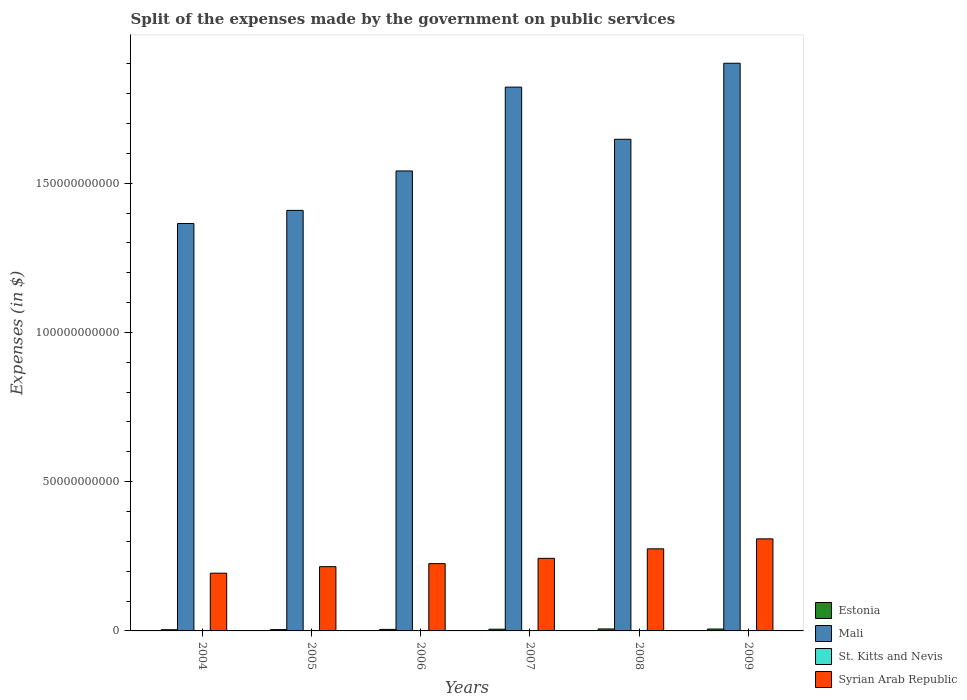How many groups of bars are there?
Give a very brief answer. 6. How many bars are there on the 6th tick from the right?
Offer a very short reply. 4. What is the label of the 2nd group of bars from the left?
Provide a succinct answer. 2005. In how many cases, is the number of bars for a given year not equal to the number of legend labels?
Your response must be concise. 0. What is the expenses made by the government on public services in Syrian Arab Republic in 2007?
Provide a short and direct response. 2.43e+1. Across all years, what is the maximum expenses made by the government on public services in Estonia?
Make the answer very short. 6.60e+08. Across all years, what is the minimum expenses made by the government on public services in Estonia?
Your answer should be very brief. 4.04e+08. In which year was the expenses made by the government on public services in Syrian Arab Republic maximum?
Give a very brief answer. 2009. In which year was the expenses made by the government on public services in Mali minimum?
Your response must be concise. 2004. What is the total expenses made by the government on public services in Estonia in the graph?
Give a very brief answer. 3.24e+09. What is the difference between the expenses made by the government on public services in Syrian Arab Republic in 2007 and that in 2009?
Ensure brevity in your answer.  -6.52e+09. What is the difference between the expenses made by the government on public services in Mali in 2008 and the expenses made by the government on public services in Estonia in 2004?
Give a very brief answer. 1.64e+11. What is the average expenses made by the government on public services in St. Kitts and Nevis per year?
Ensure brevity in your answer.  1.24e+08. In the year 2005, what is the difference between the expenses made by the government on public services in Estonia and expenses made by the government on public services in Syrian Arab Republic?
Make the answer very short. -2.11e+1. In how many years, is the expenses made by the government on public services in Estonia greater than 50000000000 $?
Make the answer very short. 0. What is the ratio of the expenses made by the government on public services in St. Kitts and Nevis in 2004 to that in 2005?
Make the answer very short. 0.84. What is the difference between the highest and the second highest expenses made by the government on public services in Syrian Arab Republic?
Your answer should be compact. 3.34e+09. What is the difference between the highest and the lowest expenses made by the government on public services in St. Kitts and Nevis?
Offer a very short reply. 4.46e+07. Is it the case that in every year, the sum of the expenses made by the government on public services in Mali and expenses made by the government on public services in Estonia is greater than the sum of expenses made by the government on public services in St. Kitts and Nevis and expenses made by the government on public services in Syrian Arab Republic?
Make the answer very short. Yes. What does the 3rd bar from the left in 2008 represents?
Make the answer very short. St. Kitts and Nevis. What does the 2nd bar from the right in 2007 represents?
Your answer should be very brief. St. Kitts and Nevis. Are all the bars in the graph horizontal?
Provide a succinct answer. No. Does the graph contain grids?
Keep it short and to the point. No. Where does the legend appear in the graph?
Provide a succinct answer. Bottom right. How are the legend labels stacked?
Provide a succinct answer. Vertical. What is the title of the graph?
Make the answer very short. Split of the expenses made by the government on public services. Does "Maldives" appear as one of the legend labels in the graph?
Your response must be concise. No. What is the label or title of the Y-axis?
Offer a very short reply. Expenses (in $). What is the Expenses (in $) of Estonia in 2004?
Offer a terse response. 4.04e+08. What is the Expenses (in $) of Mali in 2004?
Your answer should be compact. 1.36e+11. What is the Expenses (in $) in St. Kitts and Nevis in 2004?
Your answer should be compact. 9.58e+07. What is the Expenses (in $) in Syrian Arab Republic in 2004?
Provide a short and direct response. 1.93e+1. What is the Expenses (in $) of Estonia in 2005?
Provide a short and direct response. 4.46e+08. What is the Expenses (in $) of Mali in 2005?
Your answer should be compact. 1.41e+11. What is the Expenses (in $) in St. Kitts and Nevis in 2005?
Give a very brief answer. 1.15e+08. What is the Expenses (in $) in Syrian Arab Republic in 2005?
Your response must be concise. 2.15e+1. What is the Expenses (in $) of Estonia in 2006?
Offer a very short reply. 5.12e+08. What is the Expenses (in $) of Mali in 2006?
Your answer should be very brief. 1.54e+11. What is the Expenses (in $) in St. Kitts and Nevis in 2006?
Keep it short and to the point. 1.29e+08. What is the Expenses (in $) of Syrian Arab Republic in 2006?
Provide a succinct answer. 2.25e+1. What is the Expenses (in $) of Estonia in 2007?
Your answer should be compact. 5.78e+08. What is the Expenses (in $) in Mali in 2007?
Offer a very short reply. 1.82e+11. What is the Expenses (in $) of St. Kitts and Nevis in 2007?
Your answer should be compact. 1.40e+08. What is the Expenses (in $) in Syrian Arab Republic in 2007?
Your answer should be compact. 2.43e+1. What is the Expenses (in $) of Estonia in 2008?
Provide a short and direct response. 6.60e+08. What is the Expenses (in $) in Mali in 2008?
Make the answer very short. 1.65e+11. What is the Expenses (in $) in St. Kitts and Nevis in 2008?
Keep it short and to the point. 1.37e+08. What is the Expenses (in $) in Syrian Arab Republic in 2008?
Your answer should be very brief. 2.75e+1. What is the Expenses (in $) in Estonia in 2009?
Your answer should be compact. 6.36e+08. What is the Expenses (in $) in Mali in 2009?
Provide a short and direct response. 1.90e+11. What is the Expenses (in $) in St. Kitts and Nevis in 2009?
Your answer should be compact. 1.29e+08. What is the Expenses (in $) of Syrian Arab Republic in 2009?
Keep it short and to the point. 3.08e+1. Across all years, what is the maximum Expenses (in $) of Estonia?
Provide a short and direct response. 6.60e+08. Across all years, what is the maximum Expenses (in $) of Mali?
Keep it short and to the point. 1.90e+11. Across all years, what is the maximum Expenses (in $) of St. Kitts and Nevis?
Offer a very short reply. 1.40e+08. Across all years, what is the maximum Expenses (in $) in Syrian Arab Republic?
Make the answer very short. 3.08e+1. Across all years, what is the minimum Expenses (in $) of Estonia?
Make the answer very short. 4.04e+08. Across all years, what is the minimum Expenses (in $) in Mali?
Offer a terse response. 1.36e+11. Across all years, what is the minimum Expenses (in $) of St. Kitts and Nevis?
Keep it short and to the point. 9.58e+07. Across all years, what is the minimum Expenses (in $) in Syrian Arab Republic?
Ensure brevity in your answer.  1.93e+1. What is the total Expenses (in $) in Estonia in the graph?
Make the answer very short. 3.24e+09. What is the total Expenses (in $) in Mali in the graph?
Provide a short and direct response. 9.69e+11. What is the total Expenses (in $) in St. Kitts and Nevis in the graph?
Your response must be concise. 7.47e+08. What is the total Expenses (in $) in Syrian Arab Republic in the graph?
Ensure brevity in your answer.  1.46e+11. What is the difference between the Expenses (in $) of Estonia in 2004 and that in 2005?
Keep it short and to the point. -4.19e+07. What is the difference between the Expenses (in $) of Mali in 2004 and that in 2005?
Your answer should be compact. -4.40e+09. What is the difference between the Expenses (in $) of St. Kitts and Nevis in 2004 and that in 2005?
Give a very brief answer. -1.89e+07. What is the difference between the Expenses (in $) of Syrian Arab Republic in 2004 and that in 2005?
Give a very brief answer. -2.19e+09. What is the difference between the Expenses (in $) of Estonia in 2004 and that in 2006?
Offer a very short reply. -1.07e+08. What is the difference between the Expenses (in $) of Mali in 2004 and that in 2006?
Keep it short and to the point. -1.76e+1. What is the difference between the Expenses (in $) of St. Kitts and Nevis in 2004 and that in 2006?
Provide a succinct answer. -3.36e+07. What is the difference between the Expenses (in $) in Syrian Arab Republic in 2004 and that in 2006?
Ensure brevity in your answer.  -3.20e+09. What is the difference between the Expenses (in $) in Estonia in 2004 and that in 2007?
Your answer should be very brief. -1.74e+08. What is the difference between the Expenses (in $) of Mali in 2004 and that in 2007?
Give a very brief answer. -4.57e+1. What is the difference between the Expenses (in $) of St. Kitts and Nevis in 2004 and that in 2007?
Your answer should be compact. -4.46e+07. What is the difference between the Expenses (in $) in Syrian Arab Republic in 2004 and that in 2007?
Your response must be concise. -4.97e+09. What is the difference between the Expenses (in $) of Estonia in 2004 and that in 2008?
Your response must be concise. -2.56e+08. What is the difference between the Expenses (in $) of Mali in 2004 and that in 2008?
Provide a succinct answer. -2.82e+1. What is the difference between the Expenses (in $) of St. Kitts and Nevis in 2004 and that in 2008?
Offer a very short reply. -4.14e+07. What is the difference between the Expenses (in $) in Syrian Arab Republic in 2004 and that in 2008?
Offer a terse response. -8.16e+09. What is the difference between the Expenses (in $) in Estonia in 2004 and that in 2009?
Make the answer very short. -2.32e+08. What is the difference between the Expenses (in $) of Mali in 2004 and that in 2009?
Provide a short and direct response. -5.37e+1. What is the difference between the Expenses (in $) of St. Kitts and Nevis in 2004 and that in 2009?
Offer a terse response. -3.33e+07. What is the difference between the Expenses (in $) in Syrian Arab Republic in 2004 and that in 2009?
Your answer should be compact. -1.15e+1. What is the difference between the Expenses (in $) in Estonia in 2005 and that in 2006?
Provide a succinct answer. -6.51e+07. What is the difference between the Expenses (in $) in Mali in 2005 and that in 2006?
Offer a terse response. -1.32e+1. What is the difference between the Expenses (in $) in St. Kitts and Nevis in 2005 and that in 2006?
Provide a succinct answer. -1.47e+07. What is the difference between the Expenses (in $) of Syrian Arab Republic in 2005 and that in 2006?
Ensure brevity in your answer.  -1.01e+09. What is the difference between the Expenses (in $) of Estonia in 2005 and that in 2007?
Your answer should be compact. -1.32e+08. What is the difference between the Expenses (in $) in Mali in 2005 and that in 2007?
Give a very brief answer. -4.13e+1. What is the difference between the Expenses (in $) in St. Kitts and Nevis in 2005 and that in 2007?
Your answer should be compact. -2.57e+07. What is the difference between the Expenses (in $) of Syrian Arab Republic in 2005 and that in 2007?
Ensure brevity in your answer.  -2.79e+09. What is the difference between the Expenses (in $) of Estonia in 2005 and that in 2008?
Give a very brief answer. -2.14e+08. What is the difference between the Expenses (in $) in Mali in 2005 and that in 2008?
Offer a very short reply. -2.38e+1. What is the difference between the Expenses (in $) in St. Kitts and Nevis in 2005 and that in 2008?
Your answer should be very brief. -2.25e+07. What is the difference between the Expenses (in $) of Syrian Arab Republic in 2005 and that in 2008?
Provide a short and direct response. -5.97e+09. What is the difference between the Expenses (in $) in Estonia in 2005 and that in 2009?
Provide a short and direct response. -1.90e+08. What is the difference between the Expenses (in $) of Mali in 2005 and that in 2009?
Keep it short and to the point. -4.93e+1. What is the difference between the Expenses (in $) in St. Kitts and Nevis in 2005 and that in 2009?
Your answer should be compact. -1.44e+07. What is the difference between the Expenses (in $) in Syrian Arab Republic in 2005 and that in 2009?
Your response must be concise. -9.31e+09. What is the difference between the Expenses (in $) in Estonia in 2006 and that in 2007?
Your answer should be compact. -6.65e+07. What is the difference between the Expenses (in $) of Mali in 2006 and that in 2007?
Provide a succinct answer. -2.81e+1. What is the difference between the Expenses (in $) of St. Kitts and Nevis in 2006 and that in 2007?
Your response must be concise. -1.10e+07. What is the difference between the Expenses (in $) of Syrian Arab Republic in 2006 and that in 2007?
Keep it short and to the point. -1.78e+09. What is the difference between the Expenses (in $) in Estonia in 2006 and that in 2008?
Give a very brief answer. -1.49e+08. What is the difference between the Expenses (in $) in Mali in 2006 and that in 2008?
Your answer should be very brief. -1.06e+1. What is the difference between the Expenses (in $) in St. Kitts and Nevis in 2006 and that in 2008?
Provide a succinct answer. -7.80e+06. What is the difference between the Expenses (in $) of Syrian Arab Republic in 2006 and that in 2008?
Ensure brevity in your answer.  -4.96e+09. What is the difference between the Expenses (in $) of Estonia in 2006 and that in 2009?
Your answer should be compact. -1.25e+08. What is the difference between the Expenses (in $) of Mali in 2006 and that in 2009?
Your response must be concise. -3.61e+1. What is the difference between the Expenses (in $) in St. Kitts and Nevis in 2006 and that in 2009?
Your answer should be very brief. 3.00e+05. What is the difference between the Expenses (in $) in Syrian Arab Republic in 2006 and that in 2009?
Provide a succinct answer. -8.30e+09. What is the difference between the Expenses (in $) in Estonia in 2007 and that in 2008?
Make the answer very short. -8.21e+07. What is the difference between the Expenses (in $) of Mali in 2007 and that in 2008?
Your response must be concise. 1.75e+1. What is the difference between the Expenses (in $) of St. Kitts and Nevis in 2007 and that in 2008?
Offer a very short reply. 3.20e+06. What is the difference between the Expenses (in $) in Syrian Arab Republic in 2007 and that in 2008?
Give a very brief answer. -3.19e+09. What is the difference between the Expenses (in $) in Estonia in 2007 and that in 2009?
Keep it short and to the point. -5.85e+07. What is the difference between the Expenses (in $) of Mali in 2007 and that in 2009?
Keep it short and to the point. -8.00e+09. What is the difference between the Expenses (in $) of St. Kitts and Nevis in 2007 and that in 2009?
Provide a short and direct response. 1.13e+07. What is the difference between the Expenses (in $) of Syrian Arab Republic in 2007 and that in 2009?
Keep it short and to the point. -6.52e+09. What is the difference between the Expenses (in $) of Estonia in 2008 and that in 2009?
Make the answer very short. 2.36e+07. What is the difference between the Expenses (in $) of Mali in 2008 and that in 2009?
Keep it short and to the point. -2.55e+1. What is the difference between the Expenses (in $) in St. Kitts and Nevis in 2008 and that in 2009?
Your response must be concise. 8.10e+06. What is the difference between the Expenses (in $) of Syrian Arab Republic in 2008 and that in 2009?
Make the answer very short. -3.34e+09. What is the difference between the Expenses (in $) in Estonia in 2004 and the Expenses (in $) in Mali in 2005?
Keep it short and to the point. -1.40e+11. What is the difference between the Expenses (in $) of Estonia in 2004 and the Expenses (in $) of St. Kitts and Nevis in 2005?
Give a very brief answer. 2.90e+08. What is the difference between the Expenses (in $) of Estonia in 2004 and the Expenses (in $) of Syrian Arab Republic in 2005?
Keep it short and to the point. -2.11e+1. What is the difference between the Expenses (in $) in Mali in 2004 and the Expenses (in $) in St. Kitts and Nevis in 2005?
Keep it short and to the point. 1.36e+11. What is the difference between the Expenses (in $) of Mali in 2004 and the Expenses (in $) of Syrian Arab Republic in 2005?
Make the answer very short. 1.15e+11. What is the difference between the Expenses (in $) in St. Kitts and Nevis in 2004 and the Expenses (in $) in Syrian Arab Republic in 2005?
Offer a terse response. -2.14e+1. What is the difference between the Expenses (in $) in Estonia in 2004 and the Expenses (in $) in Mali in 2006?
Ensure brevity in your answer.  -1.54e+11. What is the difference between the Expenses (in $) in Estonia in 2004 and the Expenses (in $) in St. Kitts and Nevis in 2006?
Keep it short and to the point. 2.75e+08. What is the difference between the Expenses (in $) of Estonia in 2004 and the Expenses (in $) of Syrian Arab Republic in 2006?
Keep it short and to the point. -2.21e+1. What is the difference between the Expenses (in $) in Mali in 2004 and the Expenses (in $) in St. Kitts and Nevis in 2006?
Provide a short and direct response. 1.36e+11. What is the difference between the Expenses (in $) in Mali in 2004 and the Expenses (in $) in Syrian Arab Republic in 2006?
Ensure brevity in your answer.  1.14e+11. What is the difference between the Expenses (in $) in St. Kitts and Nevis in 2004 and the Expenses (in $) in Syrian Arab Republic in 2006?
Offer a terse response. -2.25e+1. What is the difference between the Expenses (in $) of Estonia in 2004 and the Expenses (in $) of Mali in 2007?
Offer a very short reply. -1.82e+11. What is the difference between the Expenses (in $) of Estonia in 2004 and the Expenses (in $) of St. Kitts and Nevis in 2007?
Offer a terse response. 2.64e+08. What is the difference between the Expenses (in $) in Estonia in 2004 and the Expenses (in $) in Syrian Arab Republic in 2007?
Make the answer very short. -2.39e+1. What is the difference between the Expenses (in $) of Mali in 2004 and the Expenses (in $) of St. Kitts and Nevis in 2007?
Make the answer very short. 1.36e+11. What is the difference between the Expenses (in $) in Mali in 2004 and the Expenses (in $) in Syrian Arab Republic in 2007?
Your answer should be very brief. 1.12e+11. What is the difference between the Expenses (in $) of St. Kitts and Nevis in 2004 and the Expenses (in $) of Syrian Arab Republic in 2007?
Your answer should be very brief. -2.42e+1. What is the difference between the Expenses (in $) of Estonia in 2004 and the Expenses (in $) of Mali in 2008?
Your response must be concise. -1.64e+11. What is the difference between the Expenses (in $) in Estonia in 2004 and the Expenses (in $) in St. Kitts and Nevis in 2008?
Ensure brevity in your answer.  2.67e+08. What is the difference between the Expenses (in $) in Estonia in 2004 and the Expenses (in $) in Syrian Arab Republic in 2008?
Ensure brevity in your answer.  -2.71e+1. What is the difference between the Expenses (in $) of Mali in 2004 and the Expenses (in $) of St. Kitts and Nevis in 2008?
Offer a very short reply. 1.36e+11. What is the difference between the Expenses (in $) of Mali in 2004 and the Expenses (in $) of Syrian Arab Republic in 2008?
Keep it short and to the point. 1.09e+11. What is the difference between the Expenses (in $) of St. Kitts and Nevis in 2004 and the Expenses (in $) of Syrian Arab Republic in 2008?
Your response must be concise. -2.74e+1. What is the difference between the Expenses (in $) in Estonia in 2004 and the Expenses (in $) in Mali in 2009?
Offer a terse response. -1.90e+11. What is the difference between the Expenses (in $) of Estonia in 2004 and the Expenses (in $) of St. Kitts and Nevis in 2009?
Your answer should be compact. 2.75e+08. What is the difference between the Expenses (in $) in Estonia in 2004 and the Expenses (in $) in Syrian Arab Republic in 2009?
Your answer should be compact. -3.04e+1. What is the difference between the Expenses (in $) of Mali in 2004 and the Expenses (in $) of St. Kitts and Nevis in 2009?
Provide a succinct answer. 1.36e+11. What is the difference between the Expenses (in $) in Mali in 2004 and the Expenses (in $) in Syrian Arab Republic in 2009?
Offer a terse response. 1.06e+11. What is the difference between the Expenses (in $) in St. Kitts and Nevis in 2004 and the Expenses (in $) in Syrian Arab Republic in 2009?
Your response must be concise. -3.07e+1. What is the difference between the Expenses (in $) in Estonia in 2005 and the Expenses (in $) in Mali in 2006?
Make the answer very short. -1.54e+11. What is the difference between the Expenses (in $) of Estonia in 2005 and the Expenses (in $) of St. Kitts and Nevis in 2006?
Provide a succinct answer. 3.17e+08. What is the difference between the Expenses (in $) of Estonia in 2005 and the Expenses (in $) of Syrian Arab Republic in 2006?
Provide a succinct answer. -2.21e+1. What is the difference between the Expenses (in $) in Mali in 2005 and the Expenses (in $) in St. Kitts and Nevis in 2006?
Make the answer very short. 1.41e+11. What is the difference between the Expenses (in $) in Mali in 2005 and the Expenses (in $) in Syrian Arab Republic in 2006?
Offer a terse response. 1.18e+11. What is the difference between the Expenses (in $) of St. Kitts and Nevis in 2005 and the Expenses (in $) of Syrian Arab Republic in 2006?
Make the answer very short. -2.24e+1. What is the difference between the Expenses (in $) in Estonia in 2005 and the Expenses (in $) in Mali in 2007?
Make the answer very short. -1.82e+11. What is the difference between the Expenses (in $) in Estonia in 2005 and the Expenses (in $) in St. Kitts and Nevis in 2007?
Offer a very short reply. 3.06e+08. What is the difference between the Expenses (in $) of Estonia in 2005 and the Expenses (in $) of Syrian Arab Republic in 2007?
Provide a succinct answer. -2.39e+1. What is the difference between the Expenses (in $) in Mali in 2005 and the Expenses (in $) in St. Kitts and Nevis in 2007?
Your answer should be very brief. 1.41e+11. What is the difference between the Expenses (in $) in Mali in 2005 and the Expenses (in $) in Syrian Arab Republic in 2007?
Ensure brevity in your answer.  1.17e+11. What is the difference between the Expenses (in $) of St. Kitts and Nevis in 2005 and the Expenses (in $) of Syrian Arab Republic in 2007?
Your response must be concise. -2.42e+1. What is the difference between the Expenses (in $) in Estonia in 2005 and the Expenses (in $) in Mali in 2008?
Your answer should be very brief. -1.64e+11. What is the difference between the Expenses (in $) of Estonia in 2005 and the Expenses (in $) of St. Kitts and Nevis in 2008?
Make the answer very short. 3.09e+08. What is the difference between the Expenses (in $) in Estonia in 2005 and the Expenses (in $) in Syrian Arab Republic in 2008?
Ensure brevity in your answer.  -2.71e+1. What is the difference between the Expenses (in $) of Mali in 2005 and the Expenses (in $) of St. Kitts and Nevis in 2008?
Offer a terse response. 1.41e+11. What is the difference between the Expenses (in $) in Mali in 2005 and the Expenses (in $) in Syrian Arab Republic in 2008?
Make the answer very short. 1.13e+11. What is the difference between the Expenses (in $) of St. Kitts and Nevis in 2005 and the Expenses (in $) of Syrian Arab Republic in 2008?
Give a very brief answer. -2.74e+1. What is the difference between the Expenses (in $) in Estonia in 2005 and the Expenses (in $) in Mali in 2009?
Provide a short and direct response. -1.90e+11. What is the difference between the Expenses (in $) of Estonia in 2005 and the Expenses (in $) of St. Kitts and Nevis in 2009?
Give a very brief answer. 3.17e+08. What is the difference between the Expenses (in $) in Estonia in 2005 and the Expenses (in $) in Syrian Arab Republic in 2009?
Your answer should be compact. -3.04e+1. What is the difference between the Expenses (in $) in Mali in 2005 and the Expenses (in $) in St. Kitts and Nevis in 2009?
Make the answer very short. 1.41e+11. What is the difference between the Expenses (in $) of Mali in 2005 and the Expenses (in $) of Syrian Arab Republic in 2009?
Your response must be concise. 1.10e+11. What is the difference between the Expenses (in $) in St. Kitts and Nevis in 2005 and the Expenses (in $) in Syrian Arab Republic in 2009?
Ensure brevity in your answer.  -3.07e+1. What is the difference between the Expenses (in $) of Estonia in 2006 and the Expenses (in $) of Mali in 2007?
Make the answer very short. -1.82e+11. What is the difference between the Expenses (in $) in Estonia in 2006 and the Expenses (in $) in St. Kitts and Nevis in 2007?
Offer a terse response. 3.71e+08. What is the difference between the Expenses (in $) of Estonia in 2006 and the Expenses (in $) of Syrian Arab Republic in 2007?
Give a very brief answer. -2.38e+1. What is the difference between the Expenses (in $) of Mali in 2006 and the Expenses (in $) of St. Kitts and Nevis in 2007?
Provide a short and direct response. 1.54e+11. What is the difference between the Expenses (in $) in Mali in 2006 and the Expenses (in $) in Syrian Arab Republic in 2007?
Your response must be concise. 1.30e+11. What is the difference between the Expenses (in $) of St. Kitts and Nevis in 2006 and the Expenses (in $) of Syrian Arab Republic in 2007?
Your response must be concise. -2.42e+1. What is the difference between the Expenses (in $) in Estonia in 2006 and the Expenses (in $) in Mali in 2008?
Keep it short and to the point. -1.64e+11. What is the difference between the Expenses (in $) of Estonia in 2006 and the Expenses (in $) of St. Kitts and Nevis in 2008?
Keep it short and to the point. 3.74e+08. What is the difference between the Expenses (in $) of Estonia in 2006 and the Expenses (in $) of Syrian Arab Republic in 2008?
Provide a short and direct response. -2.70e+1. What is the difference between the Expenses (in $) of Mali in 2006 and the Expenses (in $) of St. Kitts and Nevis in 2008?
Your answer should be compact. 1.54e+11. What is the difference between the Expenses (in $) in Mali in 2006 and the Expenses (in $) in Syrian Arab Republic in 2008?
Keep it short and to the point. 1.27e+11. What is the difference between the Expenses (in $) in St. Kitts and Nevis in 2006 and the Expenses (in $) in Syrian Arab Republic in 2008?
Your response must be concise. -2.74e+1. What is the difference between the Expenses (in $) in Estonia in 2006 and the Expenses (in $) in Mali in 2009?
Offer a very short reply. -1.90e+11. What is the difference between the Expenses (in $) in Estonia in 2006 and the Expenses (in $) in St. Kitts and Nevis in 2009?
Offer a very short reply. 3.82e+08. What is the difference between the Expenses (in $) in Estonia in 2006 and the Expenses (in $) in Syrian Arab Republic in 2009?
Offer a terse response. -3.03e+1. What is the difference between the Expenses (in $) in Mali in 2006 and the Expenses (in $) in St. Kitts and Nevis in 2009?
Provide a short and direct response. 1.54e+11. What is the difference between the Expenses (in $) in Mali in 2006 and the Expenses (in $) in Syrian Arab Republic in 2009?
Your response must be concise. 1.23e+11. What is the difference between the Expenses (in $) in St. Kitts and Nevis in 2006 and the Expenses (in $) in Syrian Arab Republic in 2009?
Give a very brief answer. -3.07e+1. What is the difference between the Expenses (in $) of Estonia in 2007 and the Expenses (in $) of Mali in 2008?
Keep it short and to the point. -1.64e+11. What is the difference between the Expenses (in $) of Estonia in 2007 and the Expenses (in $) of St. Kitts and Nevis in 2008?
Provide a short and direct response. 4.41e+08. What is the difference between the Expenses (in $) of Estonia in 2007 and the Expenses (in $) of Syrian Arab Republic in 2008?
Your answer should be compact. -2.69e+1. What is the difference between the Expenses (in $) in Mali in 2007 and the Expenses (in $) in St. Kitts and Nevis in 2008?
Provide a succinct answer. 1.82e+11. What is the difference between the Expenses (in $) of Mali in 2007 and the Expenses (in $) of Syrian Arab Republic in 2008?
Your answer should be compact. 1.55e+11. What is the difference between the Expenses (in $) of St. Kitts and Nevis in 2007 and the Expenses (in $) of Syrian Arab Republic in 2008?
Offer a terse response. -2.74e+1. What is the difference between the Expenses (in $) of Estonia in 2007 and the Expenses (in $) of Mali in 2009?
Offer a very short reply. -1.90e+11. What is the difference between the Expenses (in $) of Estonia in 2007 and the Expenses (in $) of St. Kitts and Nevis in 2009?
Your response must be concise. 4.49e+08. What is the difference between the Expenses (in $) of Estonia in 2007 and the Expenses (in $) of Syrian Arab Republic in 2009?
Give a very brief answer. -3.03e+1. What is the difference between the Expenses (in $) in Mali in 2007 and the Expenses (in $) in St. Kitts and Nevis in 2009?
Give a very brief answer. 1.82e+11. What is the difference between the Expenses (in $) of Mali in 2007 and the Expenses (in $) of Syrian Arab Republic in 2009?
Offer a very short reply. 1.51e+11. What is the difference between the Expenses (in $) in St. Kitts and Nevis in 2007 and the Expenses (in $) in Syrian Arab Republic in 2009?
Provide a short and direct response. -3.07e+1. What is the difference between the Expenses (in $) in Estonia in 2008 and the Expenses (in $) in Mali in 2009?
Give a very brief answer. -1.90e+11. What is the difference between the Expenses (in $) in Estonia in 2008 and the Expenses (in $) in St. Kitts and Nevis in 2009?
Your answer should be compact. 5.31e+08. What is the difference between the Expenses (in $) in Estonia in 2008 and the Expenses (in $) in Syrian Arab Republic in 2009?
Keep it short and to the point. -3.02e+1. What is the difference between the Expenses (in $) in Mali in 2008 and the Expenses (in $) in St. Kitts and Nevis in 2009?
Make the answer very short. 1.65e+11. What is the difference between the Expenses (in $) of Mali in 2008 and the Expenses (in $) of Syrian Arab Republic in 2009?
Make the answer very short. 1.34e+11. What is the difference between the Expenses (in $) of St. Kitts and Nevis in 2008 and the Expenses (in $) of Syrian Arab Republic in 2009?
Your answer should be compact. -3.07e+1. What is the average Expenses (in $) in Estonia per year?
Offer a very short reply. 5.40e+08. What is the average Expenses (in $) of Mali per year?
Your answer should be compact. 1.61e+11. What is the average Expenses (in $) in St. Kitts and Nevis per year?
Keep it short and to the point. 1.24e+08. What is the average Expenses (in $) in Syrian Arab Republic per year?
Provide a succinct answer. 2.44e+1. In the year 2004, what is the difference between the Expenses (in $) of Estonia and Expenses (in $) of Mali?
Give a very brief answer. -1.36e+11. In the year 2004, what is the difference between the Expenses (in $) in Estonia and Expenses (in $) in St. Kitts and Nevis?
Keep it short and to the point. 3.09e+08. In the year 2004, what is the difference between the Expenses (in $) in Estonia and Expenses (in $) in Syrian Arab Republic?
Your answer should be very brief. -1.89e+1. In the year 2004, what is the difference between the Expenses (in $) in Mali and Expenses (in $) in St. Kitts and Nevis?
Keep it short and to the point. 1.36e+11. In the year 2004, what is the difference between the Expenses (in $) of Mali and Expenses (in $) of Syrian Arab Republic?
Your response must be concise. 1.17e+11. In the year 2004, what is the difference between the Expenses (in $) of St. Kitts and Nevis and Expenses (in $) of Syrian Arab Republic?
Give a very brief answer. -1.93e+1. In the year 2005, what is the difference between the Expenses (in $) in Estonia and Expenses (in $) in Mali?
Provide a succinct answer. -1.40e+11. In the year 2005, what is the difference between the Expenses (in $) of Estonia and Expenses (in $) of St. Kitts and Nevis?
Your response must be concise. 3.32e+08. In the year 2005, what is the difference between the Expenses (in $) of Estonia and Expenses (in $) of Syrian Arab Republic?
Provide a succinct answer. -2.11e+1. In the year 2005, what is the difference between the Expenses (in $) of Mali and Expenses (in $) of St. Kitts and Nevis?
Ensure brevity in your answer.  1.41e+11. In the year 2005, what is the difference between the Expenses (in $) of Mali and Expenses (in $) of Syrian Arab Republic?
Offer a very short reply. 1.19e+11. In the year 2005, what is the difference between the Expenses (in $) of St. Kitts and Nevis and Expenses (in $) of Syrian Arab Republic?
Offer a terse response. -2.14e+1. In the year 2006, what is the difference between the Expenses (in $) in Estonia and Expenses (in $) in Mali?
Provide a succinct answer. -1.54e+11. In the year 2006, what is the difference between the Expenses (in $) of Estonia and Expenses (in $) of St. Kitts and Nevis?
Offer a very short reply. 3.82e+08. In the year 2006, what is the difference between the Expenses (in $) in Estonia and Expenses (in $) in Syrian Arab Republic?
Offer a very short reply. -2.20e+1. In the year 2006, what is the difference between the Expenses (in $) in Mali and Expenses (in $) in St. Kitts and Nevis?
Your response must be concise. 1.54e+11. In the year 2006, what is the difference between the Expenses (in $) in Mali and Expenses (in $) in Syrian Arab Republic?
Your answer should be compact. 1.32e+11. In the year 2006, what is the difference between the Expenses (in $) in St. Kitts and Nevis and Expenses (in $) in Syrian Arab Republic?
Offer a terse response. -2.24e+1. In the year 2007, what is the difference between the Expenses (in $) of Estonia and Expenses (in $) of Mali?
Make the answer very short. -1.82e+11. In the year 2007, what is the difference between the Expenses (in $) in Estonia and Expenses (in $) in St. Kitts and Nevis?
Offer a very short reply. 4.38e+08. In the year 2007, what is the difference between the Expenses (in $) of Estonia and Expenses (in $) of Syrian Arab Republic?
Offer a terse response. -2.37e+1. In the year 2007, what is the difference between the Expenses (in $) of Mali and Expenses (in $) of St. Kitts and Nevis?
Ensure brevity in your answer.  1.82e+11. In the year 2007, what is the difference between the Expenses (in $) in Mali and Expenses (in $) in Syrian Arab Republic?
Provide a succinct answer. 1.58e+11. In the year 2007, what is the difference between the Expenses (in $) of St. Kitts and Nevis and Expenses (in $) of Syrian Arab Republic?
Provide a short and direct response. -2.42e+1. In the year 2008, what is the difference between the Expenses (in $) of Estonia and Expenses (in $) of Mali?
Ensure brevity in your answer.  -1.64e+11. In the year 2008, what is the difference between the Expenses (in $) of Estonia and Expenses (in $) of St. Kitts and Nevis?
Provide a short and direct response. 5.23e+08. In the year 2008, what is the difference between the Expenses (in $) of Estonia and Expenses (in $) of Syrian Arab Republic?
Provide a succinct answer. -2.68e+1. In the year 2008, what is the difference between the Expenses (in $) in Mali and Expenses (in $) in St. Kitts and Nevis?
Provide a succinct answer. 1.65e+11. In the year 2008, what is the difference between the Expenses (in $) in Mali and Expenses (in $) in Syrian Arab Republic?
Give a very brief answer. 1.37e+11. In the year 2008, what is the difference between the Expenses (in $) of St. Kitts and Nevis and Expenses (in $) of Syrian Arab Republic?
Offer a terse response. -2.74e+1. In the year 2009, what is the difference between the Expenses (in $) in Estonia and Expenses (in $) in Mali?
Make the answer very short. -1.90e+11. In the year 2009, what is the difference between the Expenses (in $) of Estonia and Expenses (in $) of St. Kitts and Nevis?
Offer a terse response. 5.07e+08. In the year 2009, what is the difference between the Expenses (in $) of Estonia and Expenses (in $) of Syrian Arab Republic?
Provide a succinct answer. -3.02e+1. In the year 2009, what is the difference between the Expenses (in $) in Mali and Expenses (in $) in St. Kitts and Nevis?
Make the answer very short. 1.90e+11. In the year 2009, what is the difference between the Expenses (in $) of Mali and Expenses (in $) of Syrian Arab Republic?
Offer a very short reply. 1.59e+11. In the year 2009, what is the difference between the Expenses (in $) of St. Kitts and Nevis and Expenses (in $) of Syrian Arab Republic?
Ensure brevity in your answer.  -3.07e+1. What is the ratio of the Expenses (in $) in Estonia in 2004 to that in 2005?
Keep it short and to the point. 0.91. What is the ratio of the Expenses (in $) in Mali in 2004 to that in 2005?
Keep it short and to the point. 0.97. What is the ratio of the Expenses (in $) in St. Kitts and Nevis in 2004 to that in 2005?
Keep it short and to the point. 0.84. What is the ratio of the Expenses (in $) in Syrian Arab Republic in 2004 to that in 2005?
Offer a very short reply. 0.9. What is the ratio of the Expenses (in $) in Estonia in 2004 to that in 2006?
Keep it short and to the point. 0.79. What is the ratio of the Expenses (in $) in Mali in 2004 to that in 2006?
Make the answer very short. 0.89. What is the ratio of the Expenses (in $) of St. Kitts and Nevis in 2004 to that in 2006?
Provide a succinct answer. 0.74. What is the ratio of the Expenses (in $) of Syrian Arab Republic in 2004 to that in 2006?
Your answer should be very brief. 0.86. What is the ratio of the Expenses (in $) of Estonia in 2004 to that in 2007?
Your answer should be very brief. 0.7. What is the ratio of the Expenses (in $) in Mali in 2004 to that in 2007?
Provide a succinct answer. 0.75. What is the ratio of the Expenses (in $) in St. Kitts and Nevis in 2004 to that in 2007?
Your answer should be very brief. 0.68. What is the ratio of the Expenses (in $) of Syrian Arab Republic in 2004 to that in 2007?
Your answer should be compact. 0.8. What is the ratio of the Expenses (in $) of Estonia in 2004 to that in 2008?
Give a very brief answer. 0.61. What is the ratio of the Expenses (in $) in Mali in 2004 to that in 2008?
Your answer should be compact. 0.83. What is the ratio of the Expenses (in $) in St. Kitts and Nevis in 2004 to that in 2008?
Make the answer very short. 0.7. What is the ratio of the Expenses (in $) in Syrian Arab Republic in 2004 to that in 2008?
Give a very brief answer. 0.7. What is the ratio of the Expenses (in $) of Estonia in 2004 to that in 2009?
Offer a terse response. 0.64. What is the ratio of the Expenses (in $) of Mali in 2004 to that in 2009?
Your answer should be very brief. 0.72. What is the ratio of the Expenses (in $) in St. Kitts and Nevis in 2004 to that in 2009?
Your answer should be very brief. 0.74. What is the ratio of the Expenses (in $) in Syrian Arab Republic in 2004 to that in 2009?
Your response must be concise. 0.63. What is the ratio of the Expenses (in $) in Estonia in 2005 to that in 2006?
Provide a succinct answer. 0.87. What is the ratio of the Expenses (in $) of Mali in 2005 to that in 2006?
Give a very brief answer. 0.91. What is the ratio of the Expenses (in $) of St. Kitts and Nevis in 2005 to that in 2006?
Provide a succinct answer. 0.89. What is the ratio of the Expenses (in $) of Syrian Arab Republic in 2005 to that in 2006?
Offer a very short reply. 0.96. What is the ratio of the Expenses (in $) in Estonia in 2005 to that in 2007?
Offer a terse response. 0.77. What is the ratio of the Expenses (in $) in Mali in 2005 to that in 2007?
Make the answer very short. 0.77. What is the ratio of the Expenses (in $) of St. Kitts and Nevis in 2005 to that in 2007?
Keep it short and to the point. 0.82. What is the ratio of the Expenses (in $) in Syrian Arab Republic in 2005 to that in 2007?
Your answer should be very brief. 0.89. What is the ratio of the Expenses (in $) of Estonia in 2005 to that in 2008?
Make the answer very short. 0.68. What is the ratio of the Expenses (in $) of Mali in 2005 to that in 2008?
Keep it short and to the point. 0.86. What is the ratio of the Expenses (in $) of St. Kitts and Nevis in 2005 to that in 2008?
Your answer should be compact. 0.84. What is the ratio of the Expenses (in $) of Syrian Arab Republic in 2005 to that in 2008?
Your answer should be very brief. 0.78. What is the ratio of the Expenses (in $) in Estonia in 2005 to that in 2009?
Make the answer very short. 0.7. What is the ratio of the Expenses (in $) of Mali in 2005 to that in 2009?
Ensure brevity in your answer.  0.74. What is the ratio of the Expenses (in $) of St. Kitts and Nevis in 2005 to that in 2009?
Provide a succinct answer. 0.89. What is the ratio of the Expenses (in $) in Syrian Arab Republic in 2005 to that in 2009?
Provide a succinct answer. 0.7. What is the ratio of the Expenses (in $) of Estonia in 2006 to that in 2007?
Provide a succinct answer. 0.88. What is the ratio of the Expenses (in $) in Mali in 2006 to that in 2007?
Your answer should be very brief. 0.85. What is the ratio of the Expenses (in $) of St. Kitts and Nevis in 2006 to that in 2007?
Your answer should be very brief. 0.92. What is the ratio of the Expenses (in $) of Syrian Arab Republic in 2006 to that in 2007?
Ensure brevity in your answer.  0.93. What is the ratio of the Expenses (in $) in Estonia in 2006 to that in 2008?
Your response must be concise. 0.77. What is the ratio of the Expenses (in $) in Mali in 2006 to that in 2008?
Your response must be concise. 0.94. What is the ratio of the Expenses (in $) of St. Kitts and Nevis in 2006 to that in 2008?
Keep it short and to the point. 0.94. What is the ratio of the Expenses (in $) of Syrian Arab Republic in 2006 to that in 2008?
Your answer should be very brief. 0.82. What is the ratio of the Expenses (in $) in Estonia in 2006 to that in 2009?
Make the answer very short. 0.8. What is the ratio of the Expenses (in $) of Mali in 2006 to that in 2009?
Give a very brief answer. 0.81. What is the ratio of the Expenses (in $) in Syrian Arab Republic in 2006 to that in 2009?
Provide a succinct answer. 0.73. What is the ratio of the Expenses (in $) in Estonia in 2007 to that in 2008?
Provide a succinct answer. 0.88. What is the ratio of the Expenses (in $) in Mali in 2007 to that in 2008?
Ensure brevity in your answer.  1.11. What is the ratio of the Expenses (in $) in St. Kitts and Nevis in 2007 to that in 2008?
Give a very brief answer. 1.02. What is the ratio of the Expenses (in $) in Syrian Arab Republic in 2007 to that in 2008?
Offer a very short reply. 0.88. What is the ratio of the Expenses (in $) in Estonia in 2007 to that in 2009?
Your answer should be compact. 0.91. What is the ratio of the Expenses (in $) of Mali in 2007 to that in 2009?
Provide a succinct answer. 0.96. What is the ratio of the Expenses (in $) in St. Kitts and Nevis in 2007 to that in 2009?
Provide a short and direct response. 1.09. What is the ratio of the Expenses (in $) of Syrian Arab Republic in 2007 to that in 2009?
Make the answer very short. 0.79. What is the ratio of the Expenses (in $) of Estonia in 2008 to that in 2009?
Your answer should be very brief. 1.04. What is the ratio of the Expenses (in $) in Mali in 2008 to that in 2009?
Give a very brief answer. 0.87. What is the ratio of the Expenses (in $) in St. Kitts and Nevis in 2008 to that in 2009?
Your response must be concise. 1.06. What is the ratio of the Expenses (in $) of Syrian Arab Republic in 2008 to that in 2009?
Your answer should be compact. 0.89. What is the difference between the highest and the second highest Expenses (in $) of Estonia?
Your answer should be compact. 2.36e+07. What is the difference between the highest and the second highest Expenses (in $) of Mali?
Provide a short and direct response. 8.00e+09. What is the difference between the highest and the second highest Expenses (in $) of St. Kitts and Nevis?
Offer a terse response. 3.20e+06. What is the difference between the highest and the second highest Expenses (in $) of Syrian Arab Republic?
Your answer should be very brief. 3.34e+09. What is the difference between the highest and the lowest Expenses (in $) in Estonia?
Provide a succinct answer. 2.56e+08. What is the difference between the highest and the lowest Expenses (in $) in Mali?
Your answer should be very brief. 5.37e+1. What is the difference between the highest and the lowest Expenses (in $) in St. Kitts and Nevis?
Offer a very short reply. 4.46e+07. What is the difference between the highest and the lowest Expenses (in $) of Syrian Arab Republic?
Ensure brevity in your answer.  1.15e+1. 